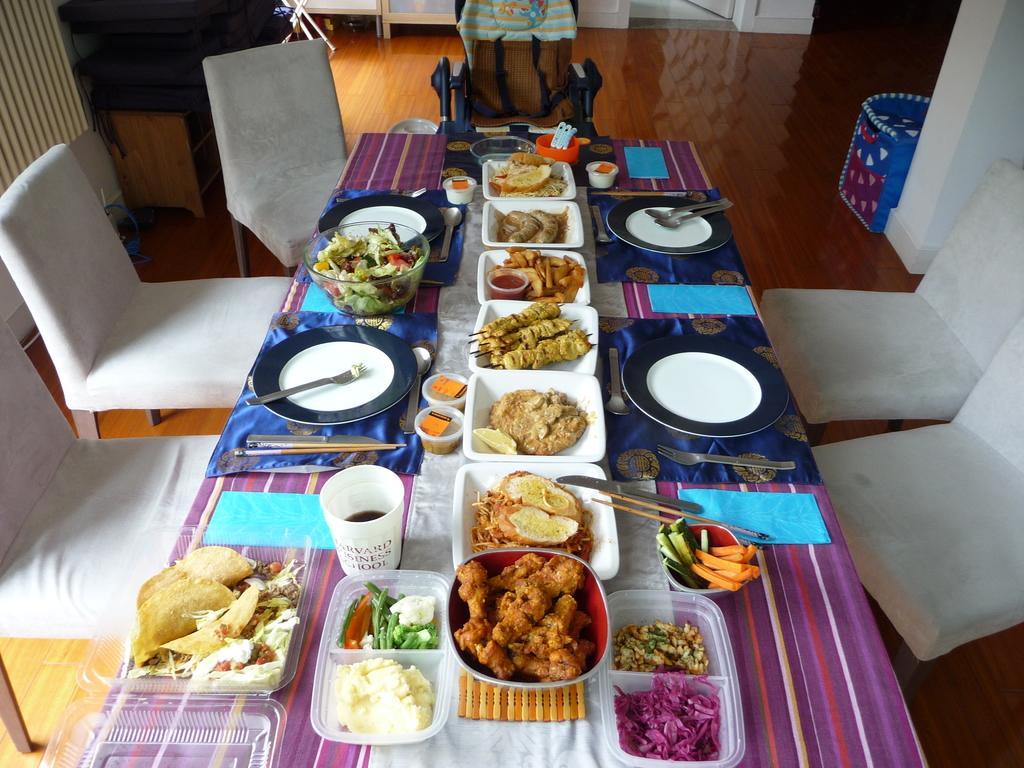In one or two sentences, can you explain what this image depicts? In this image we can see a dining table with chairs. On the right side there is a bin near to the wall. On the table there are forks, knives, chopsticks, plates, bowls, spoons and a tumbler. And there are food items in the bowls. Also there are napkins. 